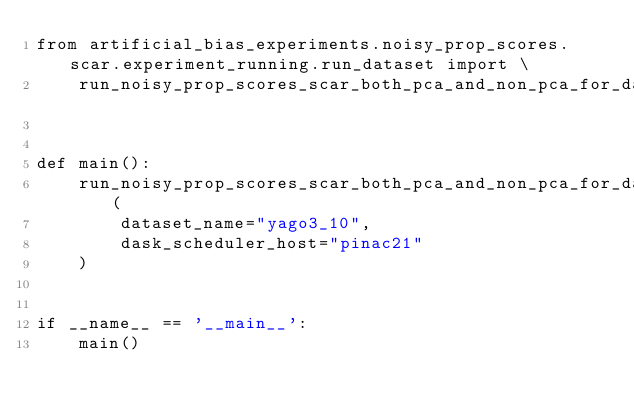<code> <loc_0><loc_0><loc_500><loc_500><_Python_>from artificial_bias_experiments.noisy_prop_scores.scar.experiment_running.run_dataset import \
    run_noisy_prop_scores_scar_both_pca_and_non_pca_for_dataset


def main():
    run_noisy_prop_scores_scar_both_pca_and_non_pca_for_dataset(
        dataset_name="yago3_10",
        dask_scheduler_host="pinac21"
    )


if __name__ == '__main__':
    main()
</code> 